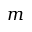Convert formula to latex. <formula><loc_0><loc_0><loc_500><loc_500>m</formula> 